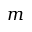Convert formula to latex. <formula><loc_0><loc_0><loc_500><loc_500>m</formula> 